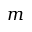Convert formula to latex. <formula><loc_0><loc_0><loc_500><loc_500>m</formula> 